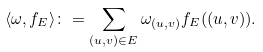<formula> <loc_0><loc_0><loc_500><loc_500>\langle \omega , f _ { E } \rangle \colon = \sum _ { ( u , v ) \in E } \omega _ { ( u , v ) } f _ { E } ( ( u , v ) ) .</formula> 